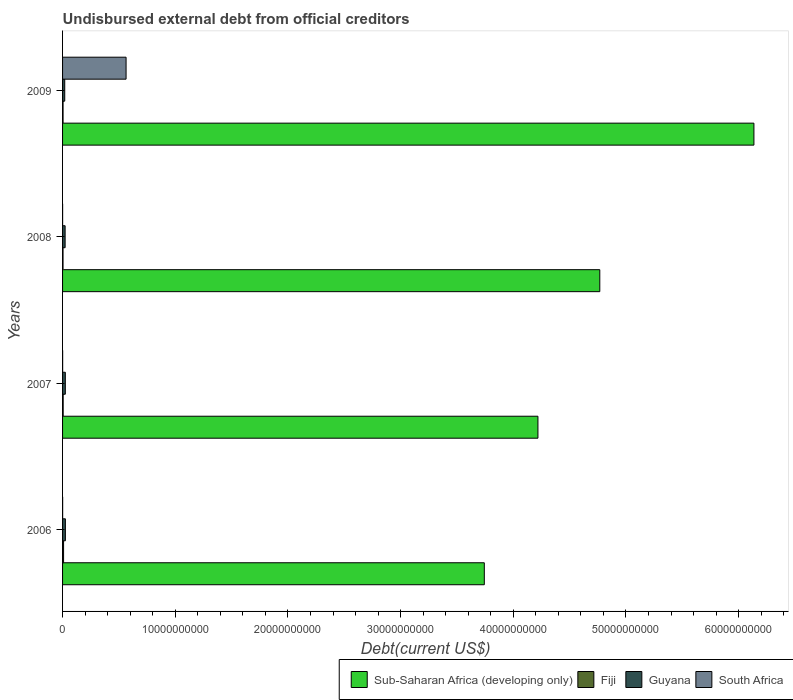How many different coloured bars are there?
Your answer should be compact. 4. How many groups of bars are there?
Keep it short and to the point. 4. How many bars are there on the 2nd tick from the bottom?
Provide a short and direct response. 4. What is the total debt in South Africa in 2006?
Offer a very short reply. 7.04e+06. Across all years, what is the maximum total debt in South Africa?
Give a very brief answer. 5.64e+09. Across all years, what is the minimum total debt in Guyana?
Offer a terse response. 1.93e+08. What is the total total debt in Fiji in the graph?
Provide a short and direct response. 2.30e+08. What is the difference between the total debt in Guyana in 2007 and that in 2008?
Your response must be concise. 1.87e+07. What is the difference between the total debt in Guyana in 2006 and the total debt in South Africa in 2009?
Keep it short and to the point. -5.39e+09. What is the average total debt in South Africa per year?
Keep it short and to the point. 1.41e+09. In the year 2007, what is the difference between the total debt in Guyana and total debt in Sub-Saharan Africa (developing only)?
Keep it short and to the point. -4.19e+1. In how many years, is the total debt in Guyana greater than 18000000000 US$?
Offer a terse response. 0. What is the ratio of the total debt in Guyana in 2008 to that in 2009?
Offer a very short reply. 1.18. Is the total debt in Guyana in 2006 less than that in 2009?
Make the answer very short. No. What is the difference between the highest and the second highest total debt in South Africa?
Your answer should be very brief. 5.63e+09. What is the difference between the highest and the lowest total debt in Sub-Saharan Africa (developing only)?
Your answer should be very brief. 2.39e+1. What does the 3rd bar from the top in 2009 represents?
Offer a terse response. Fiji. What does the 3rd bar from the bottom in 2008 represents?
Keep it short and to the point. Guyana. How many bars are there?
Ensure brevity in your answer.  16. Are all the bars in the graph horizontal?
Give a very brief answer. Yes. Does the graph contain grids?
Your response must be concise. No. Where does the legend appear in the graph?
Keep it short and to the point. Bottom right. How many legend labels are there?
Ensure brevity in your answer.  4. What is the title of the graph?
Your answer should be very brief. Undisbursed external debt from official creditors. What is the label or title of the X-axis?
Provide a succinct answer. Debt(current US$). What is the label or title of the Y-axis?
Keep it short and to the point. Years. What is the Debt(current US$) of Sub-Saharan Africa (developing only) in 2006?
Give a very brief answer. 3.74e+1. What is the Debt(current US$) of Fiji in 2006?
Offer a terse response. 9.00e+07. What is the Debt(current US$) of Guyana in 2006?
Provide a short and direct response. 2.50e+08. What is the Debt(current US$) of South Africa in 2006?
Your answer should be compact. 7.04e+06. What is the Debt(current US$) of Sub-Saharan Africa (developing only) in 2007?
Make the answer very short. 4.22e+1. What is the Debt(current US$) in Fiji in 2007?
Provide a succinct answer. 5.36e+07. What is the Debt(current US$) in Guyana in 2007?
Your answer should be compact. 2.45e+08. What is the Debt(current US$) of South Africa in 2007?
Provide a succinct answer. 7.04e+06. What is the Debt(current US$) in Sub-Saharan Africa (developing only) in 2008?
Make the answer very short. 4.77e+1. What is the Debt(current US$) in Fiji in 2008?
Your answer should be very brief. 4.18e+07. What is the Debt(current US$) in Guyana in 2008?
Your response must be concise. 2.27e+08. What is the Debt(current US$) in South Africa in 2008?
Make the answer very short. 3.94e+06. What is the Debt(current US$) of Sub-Saharan Africa (developing only) in 2009?
Provide a succinct answer. 6.14e+1. What is the Debt(current US$) of Fiji in 2009?
Your response must be concise. 4.44e+07. What is the Debt(current US$) in Guyana in 2009?
Make the answer very short. 1.93e+08. What is the Debt(current US$) of South Africa in 2009?
Provide a succinct answer. 5.64e+09. Across all years, what is the maximum Debt(current US$) of Sub-Saharan Africa (developing only)?
Offer a very short reply. 6.14e+1. Across all years, what is the maximum Debt(current US$) in Fiji?
Keep it short and to the point. 9.00e+07. Across all years, what is the maximum Debt(current US$) of Guyana?
Your response must be concise. 2.50e+08. Across all years, what is the maximum Debt(current US$) of South Africa?
Your answer should be compact. 5.64e+09. Across all years, what is the minimum Debt(current US$) in Sub-Saharan Africa (developing only)?
Keep it short and to the point. 3.74e+1. Across all years, what is the minimum Debt(current US$) of Fiji?
Your answer should be very brief. 4.18e+07. Across all years, what is the minimum Debt(current US$) in Guyana?
Give a very brief answer. 1.93e+08. Across all years, what is the minimum Debt(current US$) in South Africa?
Ensure brevity in your answer.  3.94e+06. What is the total Debt(current US$) in Sub-Saharan Africa (developing only) in the graph?
Ensure brevity in your answer.  1.89e+11. What is the total Debt(current US$) of Fiji in the graph?
Offer a terse response. 2.30e+08. What is the total Debt(current US$) in Guyana in the graph?
Make the answer very short. 9.15e+08. What is the total Debt(current US$) of South Africa in the graph?
Provide a succinct answer. 5.65e+09. What is the difference between the Debt(current US$) in Sub-Saharan Africa (developing only) in 2006 and that in 2007?
Ensure brevity in your answer.  -4.76e+09. What is the difference between the Debt(current US$) of Fiji in 2006 and that in 2007?
Your answer should be compact. 3.64e+07. What is the difference between the Debt(current US$) of Guyana in 2006 and that in 2007?
Make the answer very short. 5.15e+06. What is the difference between the Debt(current US$) in South Africa in 2006 and that in 2007?
Keep it short and to the point. 0. What is the difference between the Debt(current US$) in Sub-Saharan Africa (developing only) in 2006 and that in 2008?
Your answer should be compact. -1.02e+1. What is the difference between the Debt(current US$) in Fiji in 2006 and that in 2008?
Your response must be concise. 4.82e+07. What is the difference between the Debt(current US$) of Guyana in 2006 and that in 2008?
Provide a short and direct response. 2.38e+07. What is the difference between the Debt(current US$) of South Africa in 2006 and that in 2008?
Give a very brief answer. 3.10e+06. What is the difference between the Debt(current US$) of Sub-Saharan Africa (developing only) in 2006 and that in 2009?
Give a very brief answer. -2.39e+1. What is the difference between the Debt(current US$) of Fiji in 2006 and that in 2009?
Provide a short and direct response. 4.56e+07. What is the difference between the Debt(current US$) in Guyana in 2006 and that in 2009?
Ensure brevity in your answer.  5.77e+07. What is the difference between the Debt(current US$) of South Africa in 2006 and that in 2009?
Keep it short and to the point. -5.63e+09. What is the difference between the Debt(current US$) of Sub-Saharan Africa (developing only) in 2007 and that in 2008?
Ensure brevity in your answer.  -5.49e+09. What is the difference between the Debt(current US$) in Fiji in 2007 and that in 2008?
Your response must be concise. 1.18e+07. What is the difference between the Debt(current US$) in Guyana in 2007 and that in 2008?
Keep it short and to the point. 1.87e+07. What is the difference between the Debt(current US$) of South Africa in 2007 and that in 2008?
Your answer should be very brief. 3.10e+06. What is the difference between the Debt(current US$) of Sub-Saharan Africa (developing only) in 2007 and that in 2009?
Ensure brevity in your answer.  -1.92e+1. What is the difference between the Debt(current US$) of Fiji in 2007 and that in 2009?
Provide a succinct answer. 9.20e+06. What is the difference between the Debt(current US$) of Guyana in 2007 and that in 2009?
Your response must be concise. 5.26e+07. What is the difference between the Debt(current US$) of South Africa in 2007 and that in 2009?
Make the answer very short. -5.63e+09. What is the difference between the Debt(current US$) in Sub-Saharan Africa (developing only) in 2008 and that in 2009?
Make the answer very short. -1.37e+1. What is the difference between the Debt(current US$) of Fiji in 2008 and that in 2009?
Offer a very short reply. -2.61e+06. What is the difference between the Debt(current US$) of Guyana in 2008 and that in 2009?
Your response must be concise. 3.39e+07. What is the difference between the Debt(current US$) in South Africa in 2008 and that in 2009?
Your answer should be very brief. -5.63e+09. What is the difference between the Debt(current US$) in Sub-Saharan Africa (developing only) in 2006 and the Debt(current US$) in Fiji in 2007?
Offer a very short reply. 3.74e+1. What is the difference between the Debt(current US$) in Sub-Saharan Africa (developing only) in 2006 and the Debt(current US$) in Guyana in 2007?
Your answer should be very brief. 3.72e+1. What is the difference between the Debt(current US$) in Sub-Saharan Africa (developing only) in 2006 and the Debt(current US$) in South Africa in 2007?
Keep it short and to the point. 3.74e+1. What is the difference between the Debt(current US$) of Fiji in 2006 and the Debt(current US$) of Guyana in 2007?
Your answer should be very brief. -1.55e+08. What is the difference between the Debt(current US$) of Fiji in 2006 and the Debt(current US$) of South Africa in 2007?
Make the answer very short. 8.30e+07. What is the difference between the Debt(current US$) in Guyana in 2006 and the Debt(current US$) in South Africa in 2007?
Give a very brief answer. 2.43e+08. What is the difference between the Debt(current US$) in Sub-Saharan Africa (developing only) in 2006 and the Debt(current US$) in Fiji in 2008?
Your response must be concise. 3.74e+1. What is the difference between the Debt(current US$) of Sub-Saharan Africa (developing only) in 2006 and the Debt(current US$) of Guyana in 2008?
Keep it short and to the point. 3.72e+1. What is the difference between the Debt(current US$) in Sub-Saharan Africa (developing only) in 2006 and the Debt(current US$) in South Africa in 2008?
Keep it short and to the point. 3.74e+1. What is the difference between the Debt(current US$) of Fiji in 2006 and the Debt(current US$) of Guyana in 2008?
Provide a short and direct response. -1.37e+08. What is the difference between the Debt(current US$) of Fiji in 2006 and the Debt(current US$) of South Africa in 2008?
Your answer should be very brief. 8.61e+07. What is the difference between the Debt(current US$) of Guyana in 2006 and the Debt(current US$) of South Africa in 2008?
Make the answer very short. 2.46e+08. What is the difference between the Debt(current US$) of Sub-Saharan Africa (developing only) in 2006 and the Debt(current US$) of Fiji in 2009?
Provide a short and direct response. 3.74e+1. What is the difference between the Debt(current US$) of Sub-Saharan Africa (developing only) in 2006 and the Debt(current US$) of Guyana in 2009?
Your answer should be compact. 3.72e+1. What is the difference between the Debt(current US$) in Sub-Saharan Africa (developing only) in 2006 and the Debt(current US$) in South Africa in 2009?
Provide a short and direct response. 3.18e+1. What is the difference between the Debt(current US$) of Fiji in 2006 and the Debt(current US$) of Guyana in 2009?
Provide a short and direct response. -1.03e+08. What is the difference between the Debt(current US$) in Fiji in 2006 and the Debt(current US$) in South Africa in 2009?
Your response must be concise. -5.55e+09. What is the difference between the Debt(current US$) of Guyana in 2006 and the Debt(current US$) of South Africa in 2009?
Give a very brief answer. -5.39e+09. What is the difference between the Debt(current US$) in Sub-Saharan Africa (developing only) in 2007 and the Debt(current US$) in Fiji in 2008?
Keep it short and to the point. 4.21e+1. What is the difference between the Debt(current US$) of Sub-Saharan Africa (developing only) in 2007 and the Debt(current US$) of Guyana in 2008?
Give a very brief answer. 4.20e+1. What is the difference between the Debt(current US$) in Sub-Saharan Africa (developing only) in 2007 and the Debt(current US$) in South Africa in 2008?
Give a very brief answer. 4.22e+1. What is the difference between the Debt(current US$) of Fiji in 2007 and the Debt(current US$) of Guyana in 2008?
Provide a succinct answer. -1.73e+08. What is the difference between the Debt(current US$) of Fiji in 2007 and the Debt(current US$) of South Africa in 2008?
Your answer should be very brief. 4.97e+07. What is the difference between the Debt(current US$) in Guyana in 2007 and the Debt(current US$) in South Africa in 2008?
Give a very brief answer. 2.41e+08. What is the difference between the Debt(current US$) of Sub-Saharan Africa (developing only) in 2007 and the Debt(current US$) of Fiji in 2009?
Provide a succinct answer. 4.21e+1. What is the difference between the Debt(current US$) in Sub-Saharan Africa (developing only) in 2007 and the Debt(current US$) in Guyana in 2009?
Offer a very short reply. 4.20e+1. What is the difference between the Debt(current US$) in Sub-Saharan Africa (developing only) in 2007 and the Debt(current US$) in South Africa in 2009?
Provide a succinct answer. 3.66e+1. What is the difference between the Debt(current US$) in Fiji in 2007 and the Debt(current US$) in Guyana in 2009?
Your answer should be very brief. -1.39e+08. What is the difference between the Debt(current US$) of Fiji in 2007 and the Debt(current US$) of South Africa in 2009?
Provide a succinct answer. -5.58e+09. What is the difference between the Debt(current US$) of Guyana in 2007 and the Debt(current US$) of South Africa in 2009?
Offer a terse response. -5.39e+09. What is the difference between the Debt(current US$) in Sub-Saharan Africa (developing only) in 2008 and the Debt(current US$) in Fiji in 2009?
Keep it short and to the point. 4.76e+1. What is the difference between the Debt(current US$) of Sub-Saharan Africa (developing only) in 2008 and the Debt(current US$) of Guyana in 2009?
Provide a short and direct response. 4.75e+1. What is the difference between the Debt(current US$) of Sub-Saharan Africa (developing only) in 2008 and the Debt(current US$) of South Africa in 2009?
Offer a terse response. 4.20e+1. What is the difference between the Debt(current US$) of Fiji in 2008 and the Debt(current US$) of Guyana in 2009?
Your response must be concise. -1.51e+08. What is the difference between the Debt(current US$) of Fiji in 2008 and the Debt(current US$) of South Africa in 2009?
Your answer should be compact. -5.59e+09. What is the difference between the Debt(current US$) in Guyana in 2008 and the Debt(current US$) in South Africa in 2009?
Give a very brief answer. -5.41e+09. What is the average Debt(current US$) of Sub-Saharan Africa (developing only) per year?
Offer a very short reply. 4.72e+1. What is the average Debt(current US$) of Fiji per year?
Your answer should be very brief. 5.74e+07. What is the average Debt(current US$) of Guyana per year?
Ensure brevity in your answer.  2.29e+08. What is the average Debt(current US$) in South Africa per year?
Keep it short and to the point. 1.41e+09. In the year 2006, what is the difference between the Debt(current US$) in Sub-Saharan Africa (developing only) and Debt(current US$) in Fiji?
Ensure brevity in your answer.  3.73e+1. In the year 2006, what is the difference between the Debt(current US$) in Sub-Saharan Africa (developing only) and Debt(current US$) in Guyana?
Keep it short and to the point. 3.72e+1. In the year 2006, what is the difference between the Debt(current US$) of Sub-Saharan Africa (developing only) and Debt(current US$) of South Africa?
Offer a terse response. 3.74e+1. In the year 2006, what is the difference between the Debt(current US$) of Fiji and Debt(current US$) of Guyana?
Your response must be concise. -1.60e+08. In the year 2006, what is the difference between the Debt(current US$) in Fiji and Debt(current US$) in South Africa?
Make the answer very short. 8.30e+07. In the year 2006, what is the difference between the Debt(current US$) in Guyana and Debt(current US$) in South Africa?
Give a very brief answer. 2.43e+08. In the year 2007, what is the difference between the Debt(current US$) of Sub-Saharan Africa (developing only) and Debt(current US$) of Fiji?
Your answer should be very brief. 4.21e+1. In the year 2007, what is the difference between the Debt(current US$) of Sub-Saharan Africa (developing only) and Debt(current US$) of Guyana?
Offer a very short reply. 4.19e+1. In the year 2007, what is the difference between the Debt(current US$) of Sub-Saharan Africa (developing only) and Debt(current US$) of South Africa?
Ensure brevity in your answer.  4.22e+1. In the year 2007, what is the difference between the Debt(current US$) of Fiji and Debt(current US$) of Guyana?
Ensure brevity in your answer.  -1.92e+08. In the year 2007, what is the difference between the Debt(current US$) of Fiji and Debt(current US$) of South Africa?
Ensure brevity in your answer.  4.65e+07. In the year 2007, what is the difference between the Debt(current US$) in Guyana and Debt(current US$) in South Africa?
Your answer should be very brief. 2.38e+08. In the year 2008, what is the difference between the Debt(current US$) in Sub-Saharan Africa (developing only) and Debt(current US$) in Fiji?
Make the answer very short. 4.76e+1. In the year 2008, what is the difference between the Debt(current US$) in Sub-Saharan Africa (developing only) and Debt(current US$) in Guyana?
Provide a short and direct response. 4.75e+1. In the year 2008, what is the difference between the Debt(current US$) in Sub-Saharan Africa (developing only) and Debt(current US$) in South Africa?
Ensure brevity in your answer.  4.77e+1. In the year 2008, what is the difference between the Debt(current US$) in Fiji and Debt(current US$) in Guyana?
Offer a terse response. -1.85e+08. In the year 2008, what is the difference between the Debt(current US$) of Fiji and Debt(current US$) of South Africa?
Your response must be concise. 3.78e+07. In the year 2008, what is the difference between the Debt(current US$) of Guyana and Debt(current US$) of South Africa?
Provide a short and direct response. 2.23e+08. In the year 2009, what is the difference between the Debt(current US$) in Sub-Saharan Africa (developing only) and Debt(current US$) in Fiji?
Make the answer very short. 6.13e+1. In the year 2009, what is the difference between the Debt(current US$) of Sub-Saharan Africa (developing only) and Debt(current US$) of Guyana?
Offer a terse response. 6.12e+1. In the year 2009, what is the difference between the Debt(current US$) in Sub-Saharan Africa (developing only) and Debt(current US$) in South Africa?
Give a very brief answer. 5.57e+1. In the year 2009, what is the difference between the Debt(current US$) in Fiji and Debt(current US$) in Guyana?
Ensure brevity in your answer.  -1.48e+08. In the year 2009, what is the difference between the Debt(current US$) in Fiji and Debt(current US$) in South Africa?
Provide a short and direct response. -5.59e+09. In the year 2009, what is the difference between the Debt(current US$) in Guyana and Debt(current US$) in South Africa?
Your answer should be very brief. -5.44e+09. What is the ratio of the Debt(current US$) of Sub-Saharan Africa (developing only) in 2006 to that in 2007?
Keep it short and to the point. 0.89. What is the ratio of the Debt(current US$) of Fiji in 2006 to that in 2007?
Offer a terse response. 1.68. What is the ratio of the Debt(current US$) of Guyana in 2006 to that in 2007?
Offer a very short reply. 1.02. What is the ratio of the Debt(current US$) in South Africa in 2006 to that in 2007?
Provide a short and direct response. 1. What is the ratio of the Debt(current US$) of Sub-Saharan Africa (developing only) in 2006 to that in 2008?
Provide a short and direct response. 0.79. What is the ratio of the Debt(current US$) of Fiji in 2006 to that in 2008?
Your response must be concise. 2.15. What is the ratio of the Debt(current US$) of Guyana in 2006 to that in 2008?
Your answer should be compact. 1.11. What is the ratio of the Debt(current US$) of South Africa in 2006 to that in 2008?
Your answer should be very brief. 1.79. What is the ratio of the Debt(current US$) in Sub-Saharan Africa (developing only) in 2006 to that in 2009?
Your response must be concise. 0.61. What is the ratio of the Debt(current US$) of Fiji in 2006 to that in 2009?
Offer a very short reply. 2.03. What is the ratio of the Debt(current US$) in Guyana in 2006 to that in 2009?
Your answer should be compact. 1.3. What is the ratio of the Debt(current US$) in South Africa in 2006 to that in 2009?
Give a very brief answer. 0. What is the ratio of the Debt(current US$) of Sub-Saharan Africa (developing only) in 2007 to that in 2008?
Offer a terse response. 0.88. What is the ratio of the Debt(current US$) of Fiji in 2007 to that in 2008?
Provide a succinct answer. 1.28. What is the ratio of the Debt(current US$) of Guyana in 2007 to that in 2008?
Provide a short and direct response. 1.08. What is the ratio of the Debt(current US$) of South Africa in 2007 to that in 2008?
Ensure brevity in your answer.  1.79. What is the ratio of the Debt(current US$) in Sub-Saharan Africa (developing only) in 2007 to that in 2009?
Give a very brief answer. 0.69. What is the ratio of the Debt(current US$) in Fiji in 2007 to that in 2009?
Your answer should be compact. 1.21. What is the ratio of the Debt(current US$) in Guyana in 2007 to that in 2009?
Your response must be concise. 1.27. What is the ratio of the Debt(current US$) in South Africa in 2007 to that in 2009?
Your response must be concise. 0. What is the ratio of the Debt(current US$) of Sub-Saharan Africa (developing only) in 2008 to that in 2009?
Your answer should be compact. 0.78. What is the ratio of the Debt(current US$) of Fiji in 2008 to that in 2009?
Provide a short and direct response. 0.94. What is the ratio of the Debt(current US$) of Guyana in 2008 to that in 2009?
Your response must be concise. 1.18. What is the ratio of the Debt(current US$) of South Africa in 2008 to that in 2009?
Make the answer very short. 0. What is the difference between the highest and the second highest Debt(current US$) in Sub-Saharan Africa (developing only)?
Give a very brief answer. 1.37e+1. What is the difference between the highest and the second highest Debt(current US$) of Fiji?
Provide a short and direct response. 3.64e+07. What is the difference between the highest and the second highest Debt(current US$) of Guyana?
Keep it short and to the point. 5.15e+06. What is the difference between the highest and the second highest Debt(current US$) of South Africa?
Your answer should be compact. 5.63e+09. What is the difference between the highest and the lowest Debt(current US$) in Sub-Saharan Africa (developing only)?
Ensure brevity in your answer.  2.39e+1. What is the difference between the highest and the lowest Debt(current US$) of Fiji?
Provide a succinct answer. 4.82e+07. What is the difference between the highest and the lowest Debt(current US$) in Guyana?
Your answer should be very brief. 5.77e+07. What is the difference between the highest and the lowest Debt(current US$) in South Africa?
Give a very brief answer. 5.63e+09. 